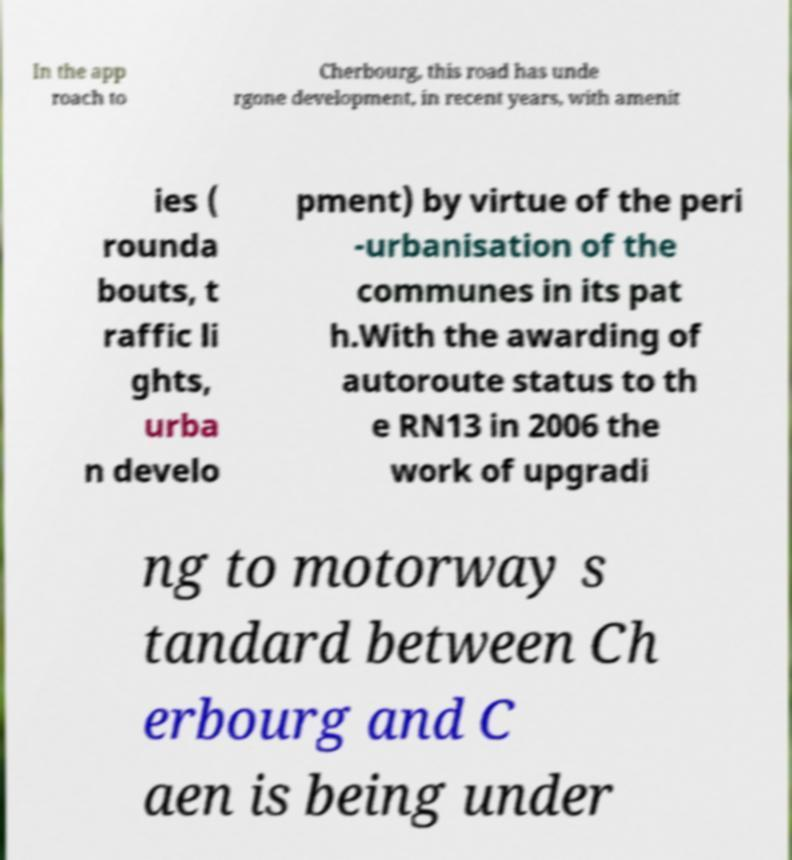What messages or text are displayed in this image? I need them in a readable, typed format. In the app roach to Cherbourg, this road has unde rgone development, in recent years, with amenit ies ( rounda bouts, t raffic li ghts, urba n develo pment) by virtue of the peri -urbanisation of the communes in its pat h.With the awarding of autoroute status to th e RN13 in 2006 the work of upgradi ng to motorway s tandard between Ch erbourg and C aen is being under 